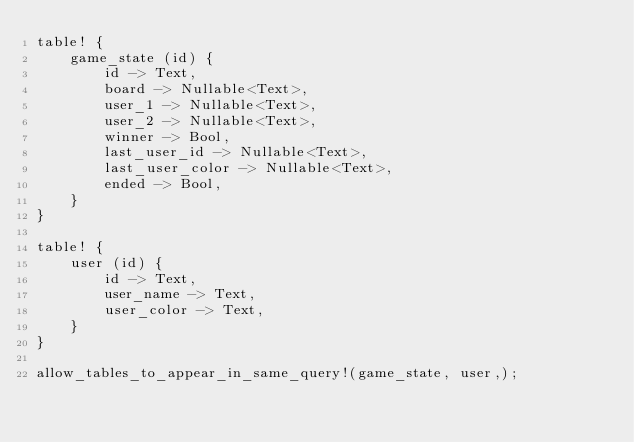Convert code to text. <code><loc_0><loc_0><loc_500><loc_500><_Rust_>table! {
    game_state (id) {
        id -> Text,
        board -> Nullable<Text>,
        user_1 -> Nullable<Text>,
        user_2 -> Nullable<Text>,
        winner -> Bool,
        last_user_id -> Nullable<Text>,
        last_user_color -> Nullable<Text>,
        ended -> Bool,
    }
}

table! {
    user (id) {
        id -> Text,
        user_name -> Text,
        user_color -> Text,
    }
}

allow_tables_to_appear_in_same_query!(game_state, user,);
</code> 